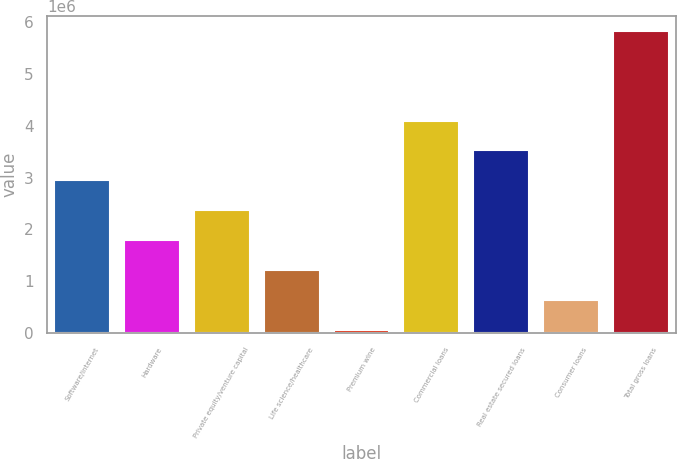Convert chart. <chart><loc_0><loc_0><loc_500><loc_500><bar_chart><fcel>Software/internet<fcel>Hardware<fcel>Private equity/venture capital<fcel>Life science/healthcare<fcel>Premium wine<fcel>Commercial loans<fcel>Real estate secured loans<fcel>Consumer loans<fcel>Total gross loans<nl><fcel>2.94691e+06<fcel>1.79638e+06<fcel>2.37164e+06<fcel>1.22111e+06<fcel>70573<fcel>4.09745e+06<fcel>3.52218e+06<fcel>645841<fcel>5.82325e+06<nl></chart> 